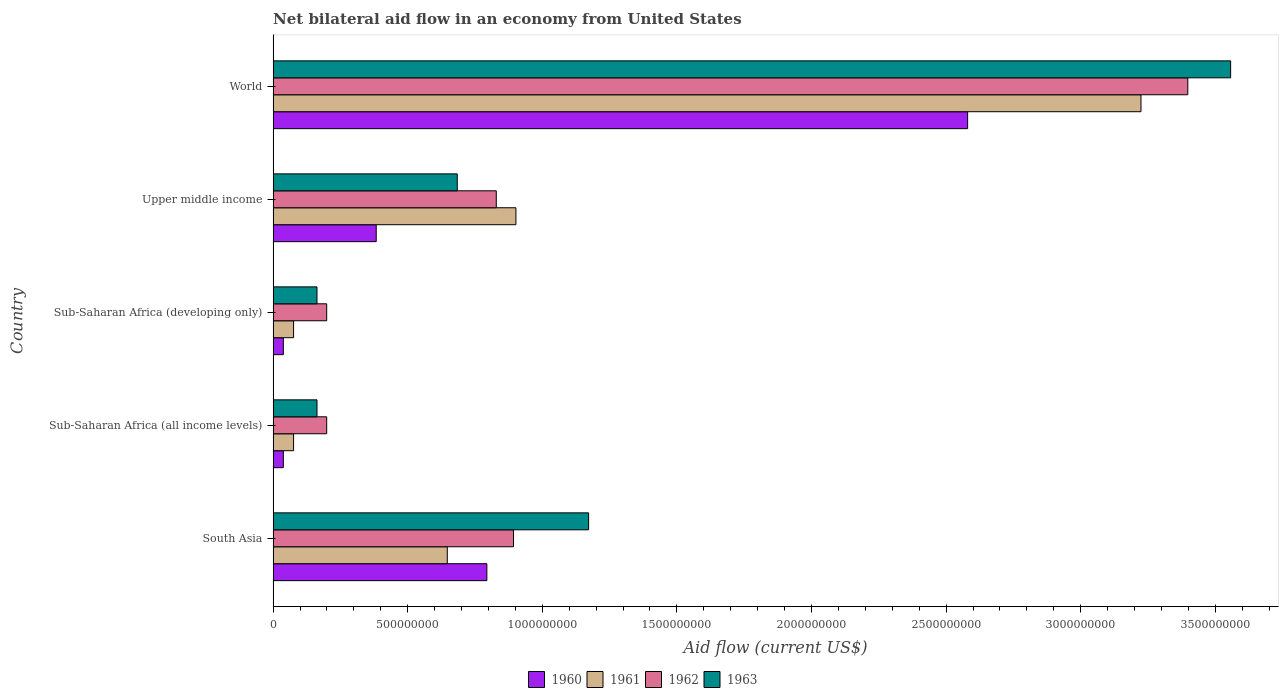How many different coloured bars are there?
Ensure brevity in your answer.  4. Are the number of bars on each tick of the Y-axis equal?
Offer a terse response. Yes. How many bars are there on the 3rd tick from the top?
Offer a very short reply. 4. How many bars are there on the 4th tick from the bottom?
Keep it short and to the point. 4. What is the label of the 4th group of bars from the top?
Offer a very short reply. Sub-Saharan Africa (all income levels). In how many cases, is the number of bars for a given country not equal to the number of legend labels?
Offer a terse response. 0. What is the net bilateral aid flow in 1962 in Upper middle income?
Your answer should be very brief. 8.29e+08. Across all countries, what is the maximum net bilateral aid flow in 1961?
Offer a terse response. 3.22e+09. Across all countries, what is the minimum net bilateral aid flow in 1960?
Your response must be concise. 3.80e+07. In which country was the net bilateral aid flow in 1961 minimum?
Offer a very short reply. Sub-Saharan Africa (all income levels). What is the total net bilateral aid flow in 1960 in the graph?
Make the answer very short. 3.83e+09. What is the difference between the net bilateral aid flow in 1963 in Sub-Saharan Africa (all income levels) and that in Upper middle income?
Keep it short and to the point. -5.21e+08. What is the difference between the net bilateral aid flow in 1960 in South Asia and the net bilateral aid flow in 1963 in Sub-Saharan Africa (developing only)?
Provide a short and direct response. 6.31e+08. What is the average net bilateral aid flow in 1963 per country?
Your response must be concise. 1.15e+09. What is the difference between the net bilateral aid flow in 1962 and net bilateral aid flow in 1961 in Sub-Saharan Africa (all income levels)?
Keep it short and to the point. 1.23e+08. What is the ratio of the net bilateral aid flow in 1962 in South Asia to that in Sub-Saharan Africa (developing only)?
Make the answer very short. 4.49. Is the net bilateral aid flow in 1962 in Sub-Saharan Africa (developing only) less than that in Upper middle income?
Offer a very short reply. Yes. What is the difference between the highest and the second highest net bilateral aid flow in 1961?
Your answer should be compact. 2.32e+09. What is the difference between the highest and the lowest net bilateral aid flow in 1961?
Provide a short and direct response. 3.15e+09. Is it the case that in every country, the sum of the net bilateral aid flow in 1963 and net bilateral aid flow in 1961 is greater than the net bilateral aid flow in 1962?
Provide a succinct answer. Yes. Are all the bars in the graph horizontal?
Provide a succinct answer. Yes. What is the difference between two consecutive major ticks on the X-axis?
Ensure brevity in your answer.  5.00e+08. Are the values on the major ticks of X-axis written in scientific E-notation?
Provide a succinct answer. No. Does the graph contain any zero values?
Make the answer very short. No. Where does the legend appear in the graph?
Provide a short and direct response. Bottom center. How many legend labels are there?
Offer a very short reply. 4. How are the legend labels stacked?
Provide a short and direct response. Horizontal. What is the title of the graph?
Provide a short and direct response. Net bilateral aid flow in an economy from United States. Does "2014" appear as one of the legend labels in the graph?
Offer a terse response. No. What is the label or title of the X-axis?
Ensure brevity in your answer.  Aid flow (current US$). What is the Aid flow (current US$) in 1960 in South Asia?
Provide a succinct answer. 7.94e+08. What is the Aid flow (current US$) in 1961 in South Asia?
Offer a terse response. 6.47e+08. What is the Aid flow (current US$) in 1962 in South Asia?
Provide a short and direct response. 8.93e+08. What is the Aid flow (current US$) in 1963 in South Asia?
Your answer should be compact. 1.17e+09. What is the Aid flow (current US$) of 1960 in Sub-Saharan Africa (all income levels)?
Your response must be concise. 3.80e+07. What is the Aid flow (current US$) of 1961 in Sub-Saharan Africa (all income levels)?
Your response must be concise. 7.60e+07. What is the Aid flow (current US$) of 1962 in Sub-Saharan Africa (all income levels)?
Offer a very short reply. 1.99e+08. What is the Aid flow (current US$) in 1963 in Sub-Saharan Africa (all income levels)?
Offer a very short reply. 1.63e+08. What is the Aid flow (current US$) of 1960 in Sub-Saharan Africa (developing only)?
Offer a terse response. 3.80e+07. What is the Aid flow (current US$) of 1961 in Sub-Saharan Africa (developing only)?
Give a very brief answer. 7.60e+07. What is the Aid flow (current US$) in 1962 in Sub-Saharan Africa (developing only)?
Your answer should be very brief. 1.99e+08. What is the Aid flow (current US$) in 1963 in Sub-Saharan Africa (developing only)?
Offer a very short reply. 1.63e+08. What is the Aid flow (current US$) in 1960 in Upper middle income?
Make the answer very short. 3.83e+08. What is the Aid flow (current US$) in 1961 in Upper middle income?
Make the answer very short. 9.02e+08. What is the Aid flow (current US$) in 1962 in Upper middle income?
Your answer should be very brief. 8.29e+08. What is the Aid flow (current US$) in 1963 in Upper middle income?
Keep it short and to the point. 6.84e+08. What is the Aid flow (current US$) of 1960 in World?
Ensure brevity in your answer.  2.58e+09. What is the Aid flow (current US$) of 1961 in World?
Provide a succinct answer. 3.22e+09. What is the Aid flow (current US$) of 1962 in World?
Offer a very short reply. 3.40e+09. What is the Aid flow (current US$) of 1963 in World?
Your answer should be compact. 3.56e+09. Across all countries, what is the maximum Aid flow (current US$) in 1960?
Your answer should be compact. 2.58e+09. Across all countries, what is the maximum Aid flow (current US$) in 1961?
Your answer should be very brief. 3.22e+09. Across all countries, what is the maximum Aid flow (current US$) in 1962?
Your response must be concise. 3.40e+09. Across all countries, what is the maximum Aid flow (current US$) in 1963?
Provide a short and direct response. 3.56e+09. Across all countries, what is the minimum Aid flow (current US$) of 1960?
Keep it short and to the point. 3.80e+07. Across all countries, what is the minimum Aid flow (current US$) of 1961?
Your answer should be compact. 7.60e+07. Across all countries, what is the minimum Aid flow (current US$) of 1962?
Offer a terse response. 1.99e+08. Across all countries, what is the minimum Aid flow (current US$) of 1963?
Your answer should be very brief. 1.63e+08. What is the total Aid flow (current US$) of 1960 in the graph?
Keep it short and to the point. 3.83e+09. What is the total Aid flow (current US$) of 1961 in the graph?
Ensure brevity in your answer.  4.92e+09. What is the total Aid flow (current US$) of 1962 in the graph?
Make the answer very short. 5.52e+09. What is the total Aid flow (current US$) in 1963 in the graph?
Your response must be concise. 5.74e+09. What is the difference between the Aid flow (current US$) of 1960 in South Asia and that in Sub-Saharan Africa (all income levels)?
Your answer should be very brief. 7.56e+08. What is the difference between the Aid flow (current US$) in 1961 in South Asia and that in Sub-Saharan Africa (all income levels)?
Make the answer very short. 5.71e+08. What is the difference between the Aid flow (current US$) in 1962 in South Asia and that in Sub-Saharan Africa (all income levels)?
Keep it short and to the point. 6.94e+08. What is the difference between the Aid flow (current US$) in 1963 in South Asia and that in Sub-Saharan Africa (all income levels)?
Your answer should be compact. 1.01e+09. What is the difference between the Aid flow (current US$) of 1960 in South Asia and that in Sub-Saharan Africa (developing only)?
Offer a very short reply. 7.56e+08. What is the difference between the Aid flow (current US$) in 1961 in South Asia and that in Sub-Saharan Africa (developing only)?
Offer a terse response. 5.71e+08. What is the difference between the Aid flow (current US$) in 1962 in South Asia and that in Sub-Saharan Africa (developing only)?
Your response must be concise. 6.94e+08. What is the difference between the Aid flow (current US$) of 1963 in South Asia and that in Sub-Saharan Africa (developing only)?
Offer a very short reply. 1.01e+09. What is the difference between the Aid flow (current US$) in 1960 in South Asia and that in Upper middle income?
Your response must be concise. 4.11e+08. What is the difference between the Aid flow (current US$) in 1961 in South Asia and that in Upper middle income?
Make the answer very short. -2.55e+08. What is the difference between the Aid flow (current US$) of 1962 in South Asia and that in Upper middle income?
Offer a very short reply. 6.40e+07. What is the difference between the Aid flow (current US$) of 1963 in South Asia and that in Upper middle income?
Your answer should be compact. 4.88e+08. What is the difference between the Aid flow (current US$) in 1960 in South Asia and that in World?
Provide a succinct answer. -1.79e+09. What is the difference between the Aid flow (current US$) in 1961 in South Asia and that in World?
Keep it short and to the point. -2.58e+09. What is the difference between the Aid flow (current US$) of 1962 in South Asia and that in World?
Your answer should be compact. -2.50e+09. What is the difference between the Aid flow (current US$) of 1963 in South Asia and that in World?
Keep it short and to the point. -2.38e+09. What is the difference between the Aid flow (current US$) of 1963 in Sub-Saharan Africa (all income levels) and that in Sub-Saharan Africa (developing only)?
Offer a terse response. 0. What is the difference between the Aid flow (current US$) in 1960 in Sub-Saharan Africa (all income levels) and that in Upper middle income?
Offer a terse response. -3.45e+08. What is the difference between the Aid flow (current US$) in 1961 in Sub-Saharan Africa (all income levels) and that in Upper middle income?
Your answer should be very brief. -8.26e+08. What is the difference between the Aid flow (current US$) of 1962 in Sub-Saharan Africa (all income levels) and that in Upper middle income?
Offer a very short reply. -6.30e+08. What is the difference between the Aid flow (current US$) of 1963 in Sub-Saharan Africa (all income levels) and that in Upper middle income?
Offer a terse response. -5.21e+08. What is the difference between the Aid flow (current US$) of 1960 in Sub-Saharan Africa (all income levels) and that in World?
Your response must be concise. -2.54e+09. What is the difference between the Aid flow (current US$) in 1961 in Sub-Saharan Africa (all income levels) and that in World?
Provide a succinct answer. -3.15e+09. What is the difference between the Aid flow (current US$) of 1962 in Sub-Saharan Africa (all income levels) and that in World?
Provide a short and direct response. -3.20e+09. What is the difference between the Aid flow (current US$) of 1963 in Sub-Saharan Africa (all income levels) and that in World?
Your response must be concise. -3.39e+09. What is the difference between the Aid flow (current US$) of 1960 in Sub-Saharan Africa (developing only) and that in Upper middle income?
Your response must be concise. -3.45e+08. What is the difference between the Aid flow (current US$) of 1961 in Sub-Saharan Africa (developing only) and that in Upper middle income?
Give a very brief answer. -8.26e+08. What is the difference between the Aid flow (current US$) of 1962 in Sub-Saharan Africa (developing only) and that in Upper middle income?
Ensure brevity in your answer.  -6.30e+08. What is the difference between the Aid flow (current US$) of 1963 in Sub-Saharan Africa (developing only) and that in Upper middle income?
Offer a very short reply. -5.21e+08. What is the difference between the Aid flow (current US$) of 1960 in Sub-Saharan Africa (developing only) and that in World?
Your answer should be very brief. -2.54e+09. What is the difference between the Aid flow (current US$) of 1961 in Sub-Saharan Africa (developing only) and that in World?
Keep it short and to the point. -3.15e+09. What is the difference between the Aid flow (current US$) in 1962 in Sub-Saharan Africa (developing only) and that in World?
Ensure brevity in your answer.  -3.20e+09. What is the difference between the Aid flow (current US$) of 1963 in Sub-Saharan Africa (developing only) and that in World?
Your answer should be very brief. -3.39e+09. What is the difference between the Aid flow (current US$) of 1960 in Upper middle income and that in World?
Offer a terse response. -2.20e+09. What is the difference between the Aid flow (current US$) in 1961 in Upper middle income and that in World?
Ensure brevity in your answer.  -2.32e+09. What is the difference between the Aid flow (current US$) in 1962 in Upper middle income and that in World?
Your answer should be compact. -2.57e+09. What is the difference between the Aid flow (current US$) in 1963 in Upper middle income and that in World?
Your answer should be very brief. -2.87e+09. What is the difference between the Aid flow (current US$) in 1960 in South Asia and the Aid flow (current US$) in 1961 in Sub-Saharan Africa (all income levels)?
Your answer should be compact. 7.18e+08. What is the difference between the Aid flow (current US$) of 1960 in South Asia and the Aid flow (current US$) of 1962 in Sub-Saharan Africa (all income levels)?
Your response must be concise. 5.95e+08. What is the difference between the Aid flow (current US$) of 1960 in South Asia and the Aid flow (current US$) of 1963 in Sub-Saharan Africa (all income levels)?
Provide a succinct answer. 6.31e+08. What is the difference between the Aid flow (current US$) in 1961 in South Asia and the Aid flow (current US$) in 1962 in Sub-Saharan Africa (all income levels)?
Ensure brevity in your answer.  4.48e+08. What is the difference between the Aid flow (current US$) of 1961 in South Asia and the Aid flow (current US$) of 1963 in Sub-Saharan Africa (all income levels)?
Provide a succinct answer. 4.84e+08. What is the difference between the Aid flow (current US$) in 1962 in South Asia and the Aid flow (current US$) in 1963 in Sub-Saharan Africa (all income levels)?
Keep it short and to the point. 7.30e+08. What is the difference between the Aid flow (current US$) of 1960 in South Asia and the Aid flow (current US$) of 1961 in Sub-Saharan Africa (developing only)?
Your answer should be very brief. 7.18e+08. What is the difference between the Aid flow (current US$) in 1960 in South Asia and the Aid flow (current US$) in 1962 in Sub-Saharan Africa (developing only)?
Give a very brief answer. 5.95e+08. What is the difference between the Aid flow (current US$) of 1960 in South Asia and the Aid flow (current US$) of 1963 in Sub-Saharan Africa (developing only)?
Ensure brevity in your answer.  6.31e+08. What is the difference between the Aid flow (current US$) of 1961 in South Asia and the Aid flow (current US$) of 1962 in Sub-Saharan Africa (developing only)?
Make the answer very short. 4.48e+08. What is the difference between the Aid flow (current US$) of 1961 in South Asia and the Aid flow (current US$) of 1963 in Sub-Saharan Africa (developing only)?
Your response must be concise. 4.84e+08. What is the difference between the Aid flow (current US$) in 1962 in South Asia and the Aid flow (current US$) in 1963 in Sub-Saharan Africa (developing only)?
Make the answer very short. 7.30e+08. What is the difference between the Aid flow (current US$) of 1960 in South Asia and the Aid flow (current US$) of 1961 in Upper middle income?
Keep it short and to the point. -1.08e+08. What is the difference between the Aid flow (current US$) of 1960 in South Asia and the Aid flow (current US$) of 1962 in Upper middle income?
Provide a short and direct response. -3.50e+07. What is the difference between the Aid flow (current US$) in 1960 in South Asia and the Aid flow (current US$) in 1963 in Upper middle income?
Provide a short and direct response. 1.10e+08. What is the difference between the Aid flow (current US$) of 1961 in South Asia and the Aid flow (current US$) of 1962 in Upper middle income?
Ensure brevity in your answer.  -1.82e+08. What is the difference between the Aid flow (current US$) in 1961 in South Asia and the Aid flow (current US$) in 1963 in Upper middle income?
Offer a very short reply. -3.70e+07. What is the difference between the Aid flow (current US$) in 1962 in South Asia and the Aid flow (current US$) in 1963 in Upper middle income?
Offer a very short reply. 2.09e+08. What is the difference between the Aid flow (current US$) in 1960 in South Asia and the Aid flow (current US$) in 1961 in World?
Keep it short and to the point. -2.43e+09. What is the difference between the Aid flow (current US$) in 1960 in South Asia and the Aid flow (current US$) in 1962 in World?
Ensure brevity in your answer.  -2.60e+09. What is the difference between the Aid flow (current US$) in 1960 in South Asia and the Aid flow (current US$) in 1963 in World?
Provide a succinct answer. -2.76e+09. What is the difference between the Aid flow (current US$) of 1961 in South Asia and the Aid flow (current US$) of 1962 in World?
Your answer should be compact. -2.75e+09. What is the difference between the Aid flow (current US$) of 1961 in South Asia and the Aid flow (current US$) of 1963 in World?
Offer a very short reply. -2.91e+09. What is the difference between the Aid flow (current US$) of 1962 in South Asia and the Aid flow (current US$) of 1963 in World?
Make the answer very short. -2.66e+09. What is the difference between the Aid flow (current US$) of 1960 in Sub-Saharan Africa (all income levels) and the Aid flow (current US$) of 1961 in Sub-Saharan Africa (developing only)?
Your response must be concise. -3.80e+07. What is the difference between the Aid flow (current US$) of 1960 in Sub-Saharan Africa (all income levels) and the Aid flow (current US$) of 1962 in Sub-Saharan Africa (developing only)?
Make the answer very short. -1.61e+08. What is the difference between the Aid flow (current US$) in 1960 in Sub-Saharan Africa (all income levels) and the Aid flow (current US$) in 1963 in Sub-Saharan Africa (developing only)?
Provide a succinct answer. -1.25e+08. What is the difference between the Aid flow (current US$) in 1961 in Sub-Saharan Africa (all income levels) and the Aid flow (current US$) in 1962 in Sub-Saharan Africa (developing only)?
Offer a very short reply. -1.23e+08. What is the difference between the Aid flow (current US$) of 1961 in Sub-Saharan Africa (all income levels) and the Aid flow (current US$) of 1963 in Sub-Saharan Africa (developing only)?
Give a very brief answer. -8.70e+07. What is the difference between the Aid flow (current US$) of 1962 in Sub-Saharan Africa (all income levels) and the Aid flow (current US$) of 1963 in Sub-Saharan Africa (developing only)?
Ensure brevity in your answer.  3.60e+07. What is the difference between the Aid flow (current US$) in 1960 in Sub-Saharan Africa (all income levels) and the Aid flow (current US$) in 1961 in Upper middle income?
Provide a short and direct response. -8.64e+08. What is the difference between the Aid flow (current US$) of 1960 in Sub-Saharan Africa (all income levels) and the Aid flow (current US$) of 1962 in Upper middle income?
Make the answer very short. -7.91e+08. What is the difference between the Aid flow (current US$) of 1960 in Sub-Saharan Africa (all income levels) and the Aid flow (current US$) of 1963 in Upper middle income?
Make the answer very short. -6.46e+08. What is the difference between the Aid flow (current US$) in 1961 in Sub-Saharan Africa (all income levels) and the Aid flow (current US$) in 1962 in Upper middle income?
Provide a short and direct response. -7.53e+08. What is the difference between the Aid flow (current US$) of 1961 in Sub-Saharan Africa (all income levels) and the Aid flow (current US$) of 1963 in Upper middle income?
Provide a succinct answer. -6.08e+08. What is the difference between the Aid flow (current US$) in 1962 in Sub-Saharan Africa (all income levels) and the Aid flow (current US$) in 1963 in Upper middle income?
Keep it short and to the point. -4.85e+08. What is the difference between the Aid flow (current US$) in 1960 in Sub-Saharan Africa (all income levels) and the Aid flow (current US$) in 1961 in World?
Offer a very short reply. -3.19e+09. What is the difference between the Aid flow (current US$) in 1960 in Sub-Saharan Africa (all income levels) and the Aid flow (current US$) in 1962 in World?
Your response must be concise. -3.36e+09. What is the difference between the Aid flow (current US$) in 1960 in Sub-Saharan Africa (all income levels) and the Aid flow (current US$) in 1963 in World?
Make the answer very short. -3.52e+09. What is the difference between the Aid flow (current US$) in 1961 in Sub-Saharan Africa (all income levels) and the Aid flow (current US$) in 1962 in World?
Keep it short and to the point. -3.32e+09. What is the difference between the Aid flow (current US$) in 1961 in Sub-Saharan Africa (all income levels) and the Aid flow (current US$) in 1963 in World?
Give a very brief answer. -3.48e+09. What is the difference between the Aid flow (current US$) of 1962 in Sub-Saharan Africa (all income levels) and the Aid flow (current US$) of 1963 in World?
Keep it short and to the point. -3.36e+09. What is the difference between the Aid flow (current US$) in 1960 in Sub-Saharan Africa (developing only) and the Aid flow (current US$) in 1961 in Upper middle income?
Your answer should be very brief. -8.64e+08. What is the difference between the Aid flow (current US$) of 1960 in Sub-Saharan Africa (developing only) and the Aid flow (current US$) of 1962 in Upper middle income?
Keep it short and to the point. -7.91e+08. What is the difference between the Aid flow (current US$) in 1960 in Sub-Saharan Africa (developing only) and the Aid flow (current US$) in 1963 in Upper middle income?
Offer a terse response. -6.46e+08. What is the difference between the Aid flow (current US$) in 1961 in Sub-Saharan Africa (developing only) and the Aid flow (current US$) in 1962 in Upper middle income?
Your answer should be compact. -7.53e+08. What is the difference between the Aid flow (current US$) in 1961 in Sub-Saharan Africa (developing only) and the Aid flow (current US$) in 1963 in Upper middle income?
Ensure brevity in your answer.  -6.08e+08. What is the difference between the Aid flow (current US$) of 1962 in Sub-Saharan Africa (developing only) and the Aid flow (current US$) of 1963 in Upper middle income?
Make the answer very short. -4.85e+08. What is the difference between the Aid flow (current US$) in 1960 in Sub-Saharan Africa (developing only) and the Aid flow (current US$) in 1961 in World?
Make the answer very short. -3.19e+09. What is the difference between the Aid flow (current US$) in 1960 in Sub-Saharan Africa (developing only) and the Aid flow (current US$) in 1962 in World?
Offer a terse response. -3.36e+09. What is the difference between the Aid flow (current US$) in 1960 in Sub-Saharan Africa (developing only) and the Aid flow (current US$) in 1963 in World?
Your response must be concise. -3.52e+09. What is the difference between the Aid flow (current US$) in 1961 in Sub-Saharan Africa (developing only) and the Aid flow (current US$) in 1962 in World?
Your answer should be very brief. -3.32e+09. What is the difference between the Aid flow (current US$) of 1961 in Sub-Saharan Africa (developing only) and the Aid flow (current US$) of 1963 in World?
Offer a terse response. -3.48e+09. What is the difference between the Aid flow (current US$) of 1962 in Sub-Saharan Africa (developing only) and the Aid flow (current US$) of 1963 in World?
Offer a terse response. -3.36e+09. What is the difference between the Aid flow (current US$) in 1960 in Upper middle income and the Aid flow (current US$) in 1961 in World?
Your answer should be very brief. -2.84e+09. What is the difference between the Aid flow (current US$) of 1960 in Upper middle income and the Aid flow (current US$) of 1962 in World?
Ensure brevity in your answer.  -3.02e+09. What is the difference between the Aid flow (current US$) in 1960 in Upper middle income and the Aid flow (current US$) in 1963 in World?
Provide a short and direct response. -3.17e+09. What is the difference between the Aid flow (current US$) of 1961 in Upper middle income and the Aid flow (current US$) of 1962 in World?
Keep it short and to the point. -2.50e+09. What is the difference between the Aid flow (current US$) of 1961 in Upper middle income and the Aid flow (current US$) of 1963 in World?
Your response must be concise. -2.66e+09. What is the difference between the Aid flow (current US$) in 1962 in Upper middle income and the Aid flow (current US$) in 1963 in World?
Keep it short and to the point. -2.73e+09. What is the average Aid flow (current US$) in 1960 per country?
Give a very brief answer. 7.67e+08. What is the average Aid flow (current US$) of 1961 per country?
Your response must be concise. 9.85e+08. What is the average Aid flow (current US$) in 1962 per country?
Offer a very short reply. 1.10e+09. What is the average Aid flow (current US$) in 1963 per country?
Make the answer very short. 1.15e+09. What is the difference between the Aid flow (current US$) of 1960 and Aid flow (current US$) of 1961 in South Asia?
Provide a succinct answer. 1.47e+08. What is the difference between the Aid flow (current US$) of 1960 and Aid flow (current US$) of 1962 in South Asia?
Keep it short and to the point. -9.90e+07. What is the difference between the Aid flow (current US$) in 1960 and Aid flow (current US$) in 1963 in South Asia?
Provide a short and direct response. -3.78e+08. What is the difference between the Aid flow (current US$) in 1961 and Aid flow (current US$) in 1962 in South Asia?
Ensure brevity in your answer.  -2.46e+08. What is the difference between the Aid flow (current US$) in 1961 and Aid flow (current US$) in 1963 in South Asia?
Give a very brief answer. -5.25e+08. What is the difference between the Aid flow (current US$) in 1962 and Aid flow (current US$) in 1963 in South Asia?
Offer a very short reply. -2.79e+08. What is the difference between the Aid flow (current US$) of 1960 and Aid flow (current US$) of 1961 in Sub-Saharan Africa (all income levels)?
Keep it short and to the point. -3.80e+07. What is the difference between the Aid flow (current US$) of 1960 and Aid flow (current US$) of 1962 in Sub-Saharan Africa (all income levels)?
Your answer should be compact. -1.61e+08. What is the difference between the Aid flow (current US$) in 1960 and Aid flow (current US$) in 1963 in Sub-Saharan Africa (all income levels)?
Provide a short and direct response. -1.25e+08. What is the difference between the Aid flow (current US$) of 1961 and Aid flow (current US$) of 1962 in Sub-Saharan Africa (all income levels)?
Give a very brief answer. -1.23e+08. What is the difference between the Aid flow (current US$) of 1961 and Aid flow (current US$) of 1963 in Sub-Saharan Africa (all income levels)?
Make the answer very short. -8.70e+07. What is the difference between the Aid flow (current US$) of 1962 and Aid flow (current US$) of 1963 in Sub-Saharan Africa (all income levels)?
Provide a succinct answer. 3.60e+07. What is the difference between the Aid flow (current US$) of 1960 and Aid flow (current US$) of 1961 in Sub-Saharan Africa (developing only)?
Your answer should be very brief. -3.80e+07. What is the difference between the Aid flow (current US$) in 1960 and Aid flow (current US$) in 1962 in Sub-Saharan Africa (developing only)?
Ensure brevity in your answer.  -1.61e+08. What is the difference between the Aid flow (current US$) of 1960 and Aid flow (current US$) of 1963 in Sub-Saharan Africa (developing only)?
Make the answer very short. -1.25e+08. What is the difference between the Aid flow (current US$) in 1961 and Aid flow (current US$) in 1962 in Sub-Saharan Africa (developing only)?
Your answer should be very brief. -1.23e+08. What is the difference between the Aid flow (current US$) in 1961 and Aid flow (current US$) in 1963 in Sub-Saharan Africa (developing only)?
Make the answer very short. -8.70e+07. What is the difference between the Aid flow (current US$) of 1962 and Aid flow (current US$) of 1963 in Sub-Saharan Africa (developing only)?
Provide a succinct answer. 3.60e+07. What is the difference between the Aid flow (current US$) of 1960 and Aid flow (current US$) of 1961 in Upper middle income?
Offer a terse response. -5.19e+08. What is the difference between the Aid flow (current US$) in 1960 and Aid flow (current US$) in 1962 in Upper middle income?
Offer a very short reply. -4.46e+08. What is the difference between the Aid flow (current US$) in 1960 and Aid flow (current US$) in 1963 in Upper middle income?
Provide a short and direct response. -3.01e+08. What is the difference between the Aid flow (current US$) in 1961 and Aid flow (current US$) in 1962 in Upper middle income?
Your answer should be compact. 7.30e+07. What is the difference between the Aid flow (current US$) of 1961 and Aid flow (current US$) of 1963 in Upper middle income?
Offer a terse response. 2.18e+08. What is the difference between the Aid flow (current US$) of 1962 and Aid flow (current US$) of 1963 in Upper middle income?
Keep it short and to the point. 1.45e+08. What is the difference between the Aid flow (current US$) of 1960 and Aid flow (current US$) of 1961 in World?
Offer a terse response. -6.44e+08. What is the difference between the Aid flow (current US$) of 1960 and Aid flow (current US$) of 1962 in World?
Make the answer very short. -8.18e+08. What is the difference between the Aid flow (current US$) of 1960 and Aid flow (current US$) of 1963 in World?
Provide a succinct answer. -9.77e+08. What is the difference between the Aid flow (current US$) of 1961 and Aid flow (current US$) of 1962 in World?
Your answer should be compact. -1.74e+08. What is the difference between the Aid flow (current US$) of 1961 and Aid flow (current US$) of 1963 in World?
Make the answer very short. -3.33e+08. What is the difference between the Aid flow (current US$) in 1962 and Aid flow (current US$) in 1963 in World?
Keep it short and to the point. -1.59e+08. What is the ratio of the Aid flow (current US$) of 1960 in South Asia to that in Sub-Saharan Africa (all income levels)?
Provide a succinct answer. 20.89. What is the ratio of the Aid flow (current US$) of 1961 in South Asia to that in Sub-Saharan Africa (all income levels)?
Keep it short and to the point. 8.51. What is the ratio of the Aid flow (current US$) in 1962 in South Asia to that in Sub-Saharan Africa (all income levels)?
Offer a very short reply. 4.49. What is the ratio of the Aid flow (current US$) of 1963 in South Asia to that in Sub-Saharan Africa (all income levels)?
Give a very brief answer. 7.19. What is the ratio of the Aid flow (current US$) of 1960 in South Asia to that in Sub-Saharan Africa (developing only)?
Provide a short and direct response. 20.89. What is the ratio of the Aid flow (current US$) of 1961 in South Asia to that in Sub-Saharan Africa (developing only)?
Keep it short and to the point. 8.51. What is the ratio of the Aid flow (current US$) of 1962 in South Asia to that in Sub-Saharan Africa (developing only)?
Provide a short and direct response. 4.49. What is the ratio of the Aid flow (current US$) in 1963 in South Asia to that in Sub-Saharan Africa (developing only)?
Give a very brief answer. 7.19. What is the ratio of the Aid flow (current US$) in 1960 in South Asia to that in Upper middle income?
Provide a succinct answer. 2.07. What is the ratio of the Aid flow (current US$) in 1961 in South Asia to that in Upper middle income?
Offer a very short reply. 0.72. What is the ratio of the Aid flow (current US$) in 1962 in South Asia to that in Upper middle income?
Your response must be concise. 1.08. What is the ratio of the Aid flow (current US$) in 1963 in South Asia to that in Upper middle income?
Provide a succinct answer. 1.71. What is the ratio of the Aid flow (current US$) of 1960 in South Asia to that in World?
Provide a succinct answer. 0.31. What is the ratio of the Aid flow (current US$) of 1961 in South Asia to that in World?
Provide a succinct answer. 0.2. What is the ratio of the Aid flow (current US$) of 1962 in South Asia to that in World?
Keep it short and to the point. 0.26. What is the ratio of the Aid flow (current US$) in 1963 in South Asia to that in World?
Give a very brief answer. 0.33. What is the ratio of the Aid flow (current US$) in 1962 in Sub-Saharan Africa (all income levels) to that in Sub-Saharan Africa (developing only)?
Provide a succinct answer. 1. What is the ratio of the Aid flow (current US$) in 1960 in Sub-Saharan Africa (all income levels) to that in Upper middle income?
Make the answer very short. 0.1. What is the ratio of the Aid flow (current US$) in 1961 in Sub-Saharan Africa (all income levels) to that in Upper middle income?
Give a very brief answer. 0.08. What is the ratio of the Aid flow (current US$) in 1962 in Sub-Saharan Africa (all income levels) to that in Upper middle income?
Keep it short and to the point. 0.24. What is the ratio of the Aid flow (current US$) of 1963 in Sub-Saharan Africa (all income levels) to that in Upper middle income?
Your response must be concise. 0.24. What is the ratio of the Aid flow (current US$) of 1960 in Sub-Saharan Africa (all income levels) to that in World?
Your answer should be very brief. 0.01. What is the ratio of the Aid flow (current US$) of 1961 in Sub-Saharan Africa (all income levels) to that in World?
Offer a terse response. 0.02. What is the ratio of the Aid flow (current US$) of 1962 in Sub-Saharan Africa (all income levels) to that in World?
Keep it short and to the point. 0.06. What is the ratio of the Aid flow (current US$) in 1963 in Sub-Saharan Africa (all income levels) to that in World?
Ensure brevity in your answer.  0.05. What is the ratio of the Aid flow (current US$) in 1960 in Sub-Saharan Africa (developing only) to that in Upper middle income?
Keep it short and to the point. 0.1. What is the ratio of the Aid flow (current US$) in 1961 in Sub-Saharan Africa (developing only) to that in Upper middle income?
Provide a short and direct response. 0.08. What is the ratio of the Aid flow (current US$) in 1962 in Sub-Saharan Africa (developing only) to that in Upper middle income?
Your answer should be very brief. 0.24. What is the ratio of the Aid flow (current US$) of 1963 in Sub-Saharan Africa (developing only) to that in Upper middle income?
Keep it short and to the point. 0.24. What is the ratio of the Aid flow (current US$) in 1960 in Sub-Saharan Africa (developing only) to that in World?
Your answer should be compact. 0.01. What is the ratio of the Aid flow (current US$) in 1961 in Sub-Saharan Africa (developing only) to that in World?
Your response must be concise. 0.02. What is the ratio of the Aid flow (current US$) of 1962 in Sub-Saharan Africa (developing only) to that in World?
Keep it short and to the point. 0.06. What is the ratio of the Aid flow (current US$) in 1963 in Sub-Saharan Africa (developing only) to that in World?
Give a very brief answer. 0.05. What is the ratio of the Aid flow (current US$) of 1960 in Upper middle income to that in World?
Offer a very short reply. 0.15. What is the ratio of the Aid flow (current US$) of 1961 in Upper middle income to that in World?
Your answer should be compact. 0.28. What is the ratio of the Aid flow (current US$) of 1962 in Upper middle income to that in World?
Make the answer very short. 0.24. What is the ratio of the Aid flow (current US$) of 1963 in Upper middle income to that in World?
Offer a terse response. 0.19. What is the difference between the highest and the second highest Aid flow (current US$) of 1960?
Keep it short and to the point. 1.79e+09. What is the difference between the highest and the second highest Aid flow (current US$) of 1961?
Provide a short and direct response. 2.32e+09. What is the difference between the highest and the second highest Aid flow (current US$) of 1962?
Offer a very short reply. 2.50e+09. What is the difference between the highest and the second highest Aid flow (current US$) of 1963?
Make the answer very short. 2.38e+09. What is the difference between the highest and the lowest Aid flow (current US$) of 1960?
Provide a succinct answer. 2.54e+09. What is the difference between the highest and the lowest Aid flow (current US$) of 1961?
Provide a short and direct response. 3.15e+09. What is the difference between the highest and the lowest Aid flow (current US$) of 1962?
Provide a succinct answer. 3.20e+09. What is the difference between the highest and the lowest Aid flow (current US$) of 1963?
Your answer should be compact. 3.39e+09. 